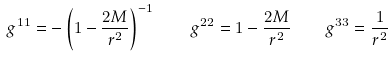Convert formula to latex. <formula><loc_0><loc_0><loc_500><loc_500>g ^ { 1 1 } = - \left ( 1 - \frac { 2 M } { r ^ { 2 } } \right ) ^ { - 1 } \quad g ^ { 2 2 } = 1 - \frac { 2 M } { r ^ { 2 } } \quad g ^ { 3 3 } = \frac { 1 } { r ^ { 2 } }</formula> 